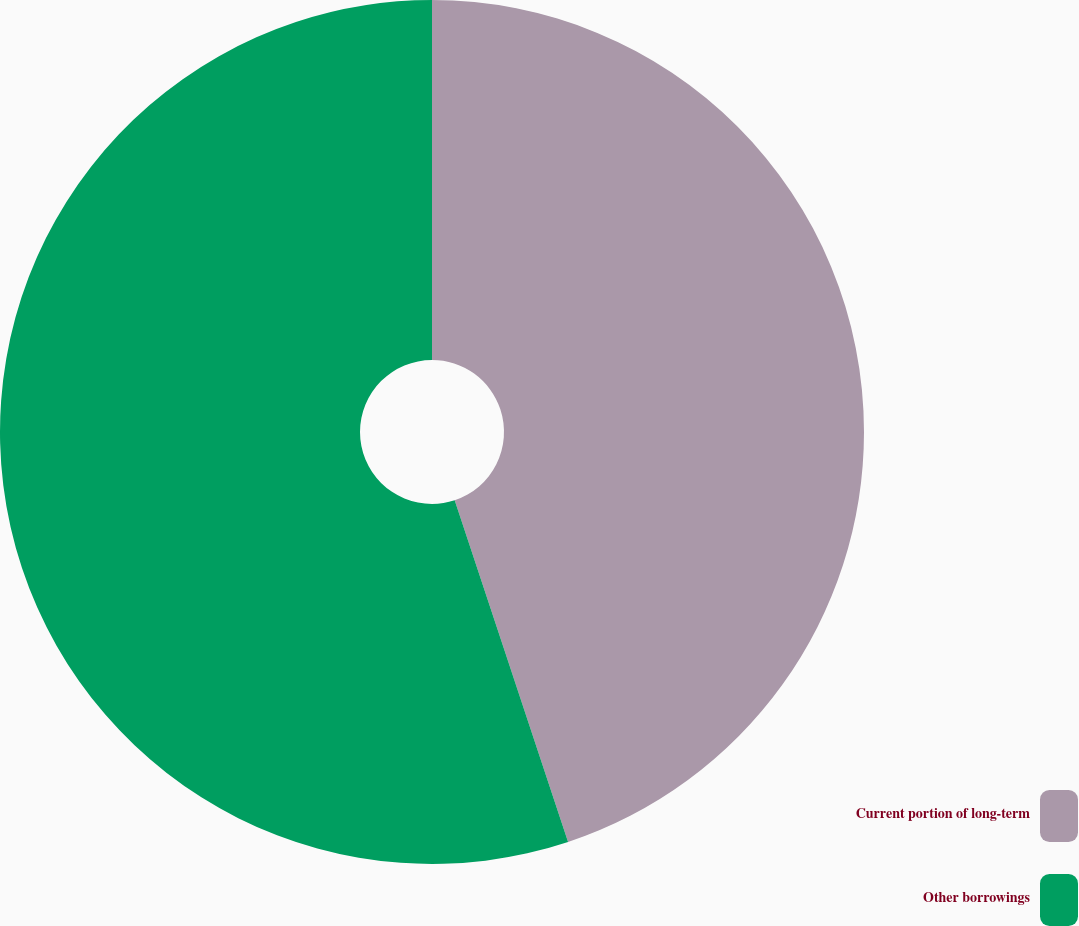<chart> <loc_0><loc_0><loc_500><loc_500><pie_chart><fcel>Current portion of long-term<fcel>Other borrowings<nl><fcel>44.9%<fcel>55.1%<nl></chart> 